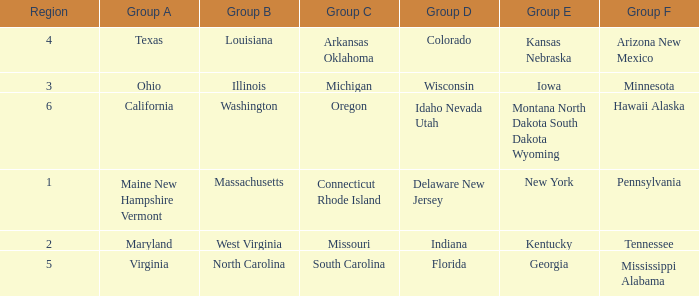Parse the table in full. {'header': ['Region', 'Group A', 'Group B', 'Group C', 'Group D', 'Group E', 'Group F'], 'rows': [['4', 'Texas', 'Louisiana', 'Arkansas Oklahoma', 'Colorado', 'Kansas Nebraska', 'Arizona New Mexico'], ['3', 'Ohio', 'Illinois', 'Michigan', 'Wisconsin', 'Iowa', 'Minnesota'], ['6', 'California', 'Washington', 'Oregon', 'Idaho Nevada Utah', 'Montana North Dakota South Dakota Wyoming', 'Hawaii Alaska'], ['1', 'Maine New Hampshire Vermont', 'Massachusetts', 'Connecticut Rhode Island', 'Delaware New Jersey', 'New York', 'Pennsylvania'], ['2', 'Maryland', 'West Virginia', 'Missouri', 'Indiana', 'Kentucky', 'Tennessee'], ['5', 'Virginia', 'North Carolina', 'South Carolina', 'Florida', 'Georgia', 'Mississippi Alabama']]} What is the group C region with Illinois as group B? Michigan. 